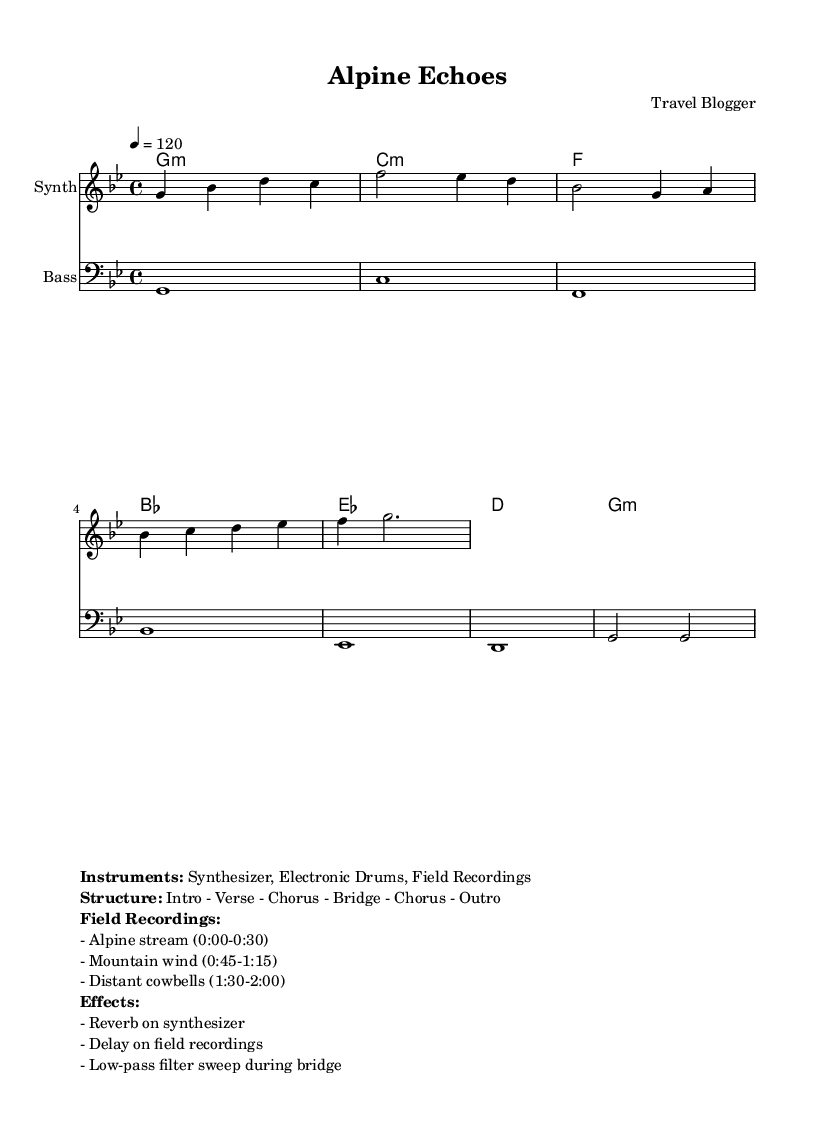What is the key signature of this music? The key signature is G minor, which has two flats (B♭ and E♭). This can be identified at the beginning of the score, where the key signature is indicated.
Answer: G minor What is the time signature of the piece? The time signature is 4/4, which means there are four beats per measure and a quarter note gets one beat. This is noted right at the beginning of the score.
Answer: 4/4 What is the tempo marking for this piece? The tempo marking is 120 beats per minute, specified as "4 = 120" in the tempo indication. This indicates the speed of the music.
Answer: 120 What instruments are used in this piece? The instruments listed are Synthesizer, Electronic Drums, and Field Recordings. This information is provided in the markup section.
Answer: Synthesizer, Electronic Drums, Field Recordings How many sections does the structure of the piece have? The structure consists of six sections: Intro, Verse, Chorus, Bridge, Chorus, and Outro. This is detailed in the markup section of the score.
Answer: Six What type of sound is featured in the field recordings? The field recordings feature sounds such as an Alpine stream, mountain wind, and distant cowbells. These are specifically listed in the markup section, showcasing the unique ambient qualities of the piece.
Answer: Alpine stream, mountain wind, distant cowbells What kind of effect is applied to the synthesizer? The effect applied to the synthesizer is Reverb, which is indicated in the markup section. This is commonly used in electronic music to create a spacious sound.
Answer: Reverb 